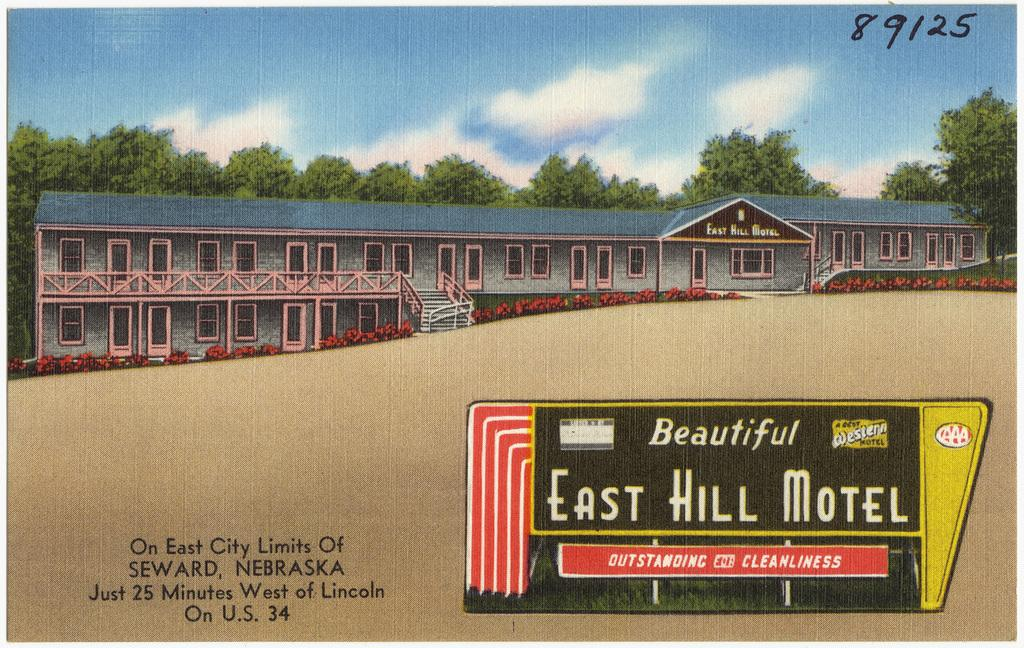<image>
Present a compact description of the photo's key features. The East Hill Motel sign that is from a book 